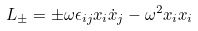<formula> <loc_0><loc_0><loc_500><loc_500>L _ { \pm } = \pm \omega \epsilon _ { i j } x _ { i } \dot { x } _ { j } - \omega ^ { 2 } x _ { i } x _ { i }</formula> 